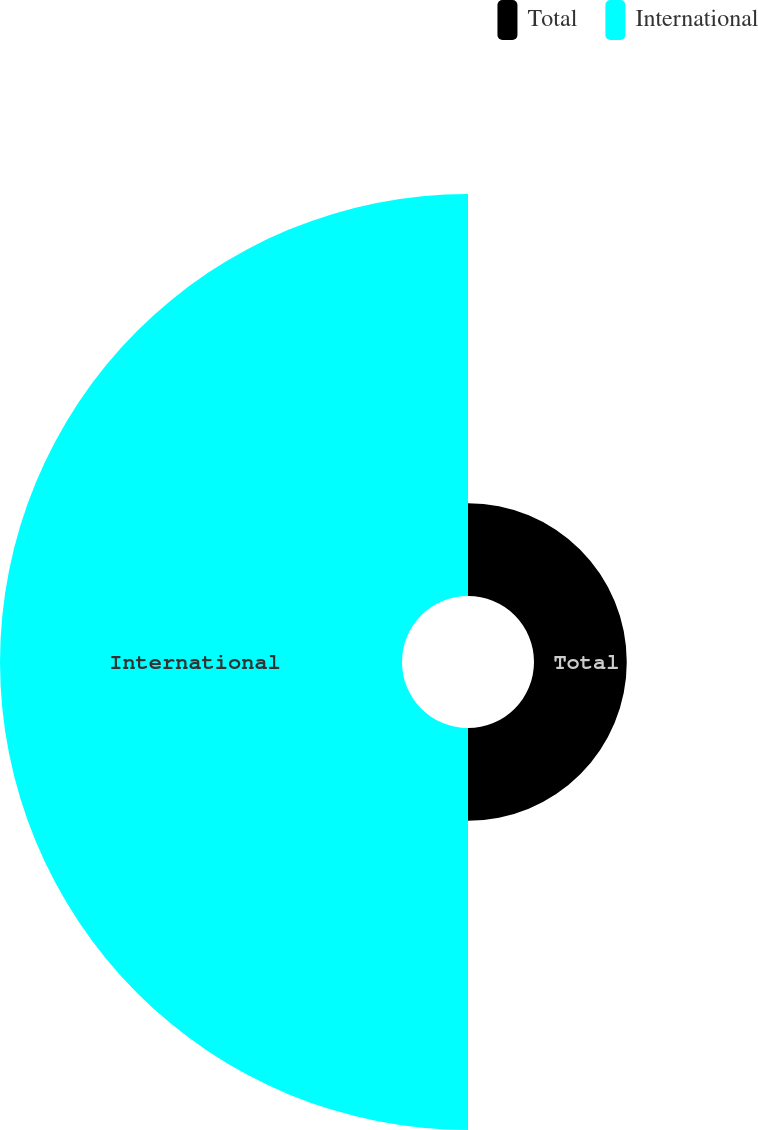Convert chart. <chart><loc_0><loc_0><loc_500><loc_500><pie_chart><fcel>Total<fcel>International<nl><fcel>18.75%<fcel>81.25%<nl></chart> 